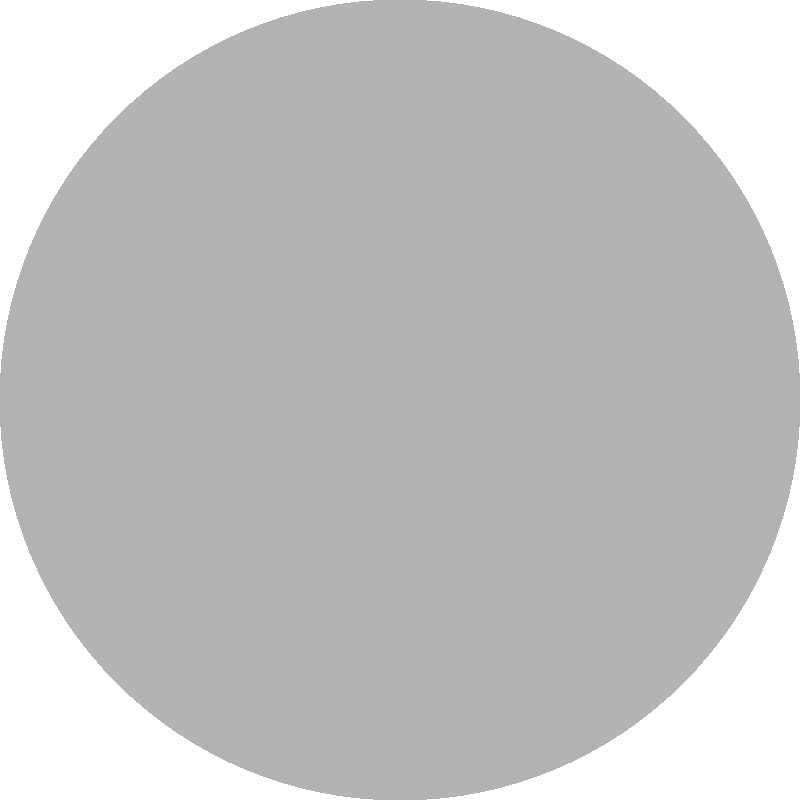In the diagram above, three overlapping circular patterns represent signal interference in a wireless communication system. Each pattern uses a different texture to symbolize signal strength and coverage. If the intensity of interference is proportional to the number of overlapping layers, which region experiences the highest level of signal interference? Explain your reasoning using the concepts of signal overlap and texture density. To determine the region with the highest level of signal interference, we need to analyze the overlapping patterns and their textures:

1. Identify the patterns:
   - Pattern A: Largest circle with light gray fill
   - Pattern B: Medium-sized circle with diagonal hatching
   - Pattern C: Smallest circle with crosshatching

2. Analyze the overlaps:
   - There are regions where two circles overlap
   - There is one region where all three circles overlap

3. Interpret the textures:
   - More complex textures (e.g., crosshatching) represent stronger signals
   - Overlapping textures increase the visual density, symbolizing increased interference

4. Evaluate the interference:
   - The region where all three circles overlap has the highest texture density
   - This region combines the light gray fill, diagonal hatching, and crosshatching

5. Apply signal interference principles:
   - In wireless communications, interference increases when multiple signals occupy the same space
   - The overlapping region represents where all three signals intersect
   - The combined effect of three signals results in the highest interference

6. Conclusion:
   - The small central region where all three circles overlap experiences the highest level of signal interference
   - This is visually represented by the densest combination of textures
Answer: The central region where all three circles overlap 